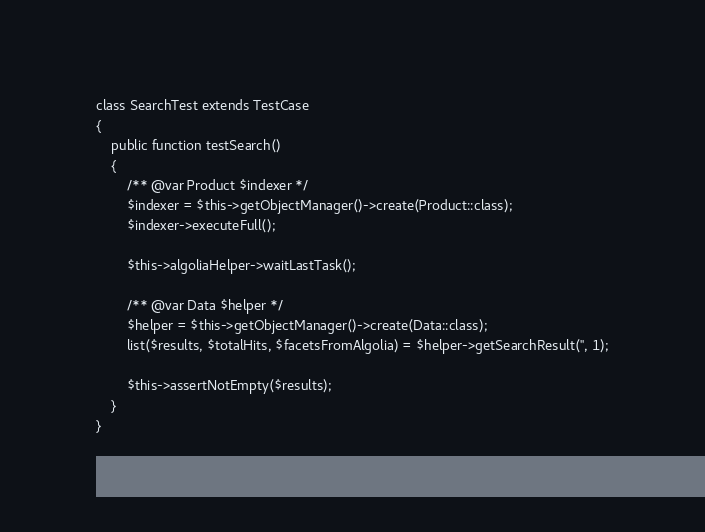Convert code to text. <code><loc_0><loc_0><loc_500><loc_500><_PHP_>class SearchTest extends TestCase
{
    public function testSearch()
    {
        /** @var Product $indexer */
        $indexer = $this->getObjectManager()->create(Product::class);
        $indexer->executeFull();

        $this->algoliaHelper->waitLastTask();

        /** @var Data $helper */
        $helper = $this->getObjectManager()->create(Data::class);
        list($results, $totalHits, $facetsFromAlgolia) = $helper->getSearchResult('', 1);

        $this->assertNotEmpty($results);
    }
}
</code> 